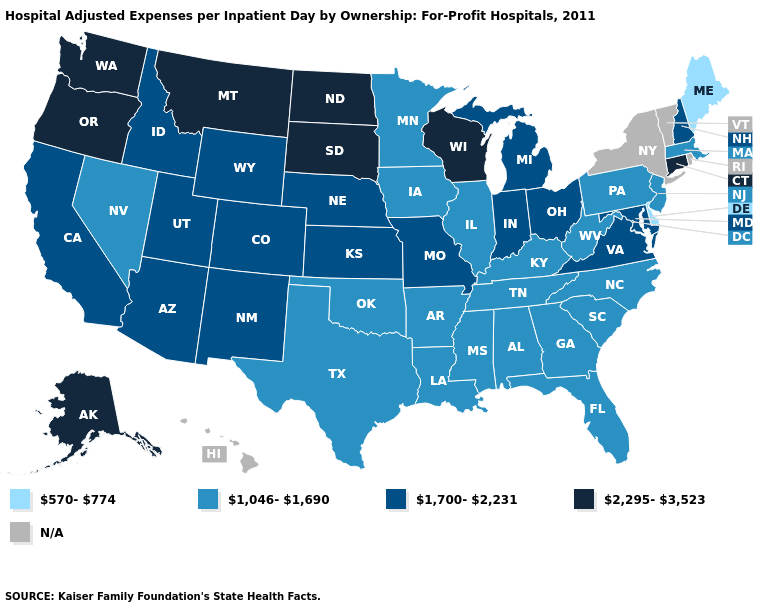Among the states that border Illinois , does Missouri have the lowest value?
Be succinct. No. Among the states that border Wyoming , does South Dakota have the highest value?
Give a very brief answer. Yes. Among the states that border New Hampshire , which have the lowest value?
Keep it brief. Maine. Name the states that have a value in the range 1,046-1,690?
Answer briefly. Alabama, Arkansas, Florida, Georgia, Illinois, Iowa, Kentucky, Louisiana, Massachusetts, Minnesota, Mississippi, Nevada, New Jersey, North Carolina, Oklahoma, Pennsylvania, South Carolina, Tennessee, Texas, West Virginia. What is the value of West Virginia?
Concise answer only. 1,046-1,690. What is the value of Kansas?
Short answer required. 1,700-2,231. Name the states that have a value in the range N/A?
Give a very brief answer. Hawaii, New York, Rhode Island, Vermont. Name the states that have a value in the range 2,295-3,523?
Concise answer only. Alaska, Connecticut, Montana, North Dakota, Oregon, South Dakota, Washington, Wisconsin. Which states have the highest value in the USA?
Concise answer only. Alaska, Connecticut, Montana, North Dakota, Oregon, South Dakota, Washington, Wisconsin. Name the states that have a value in the range N/A?
Quick response, please. Hawaii, New York, Rhode Island, Vermont. Does the first symbol in the legend represent the smallest category?
Answer briefly. Yes. Is the legend a continuous bar?
Write a very short answer. No. Does Florida have the highest value in the South?
Concise answer only. No. What is the value of Arkansas?
Concise answer only. 1,046-1,690. 